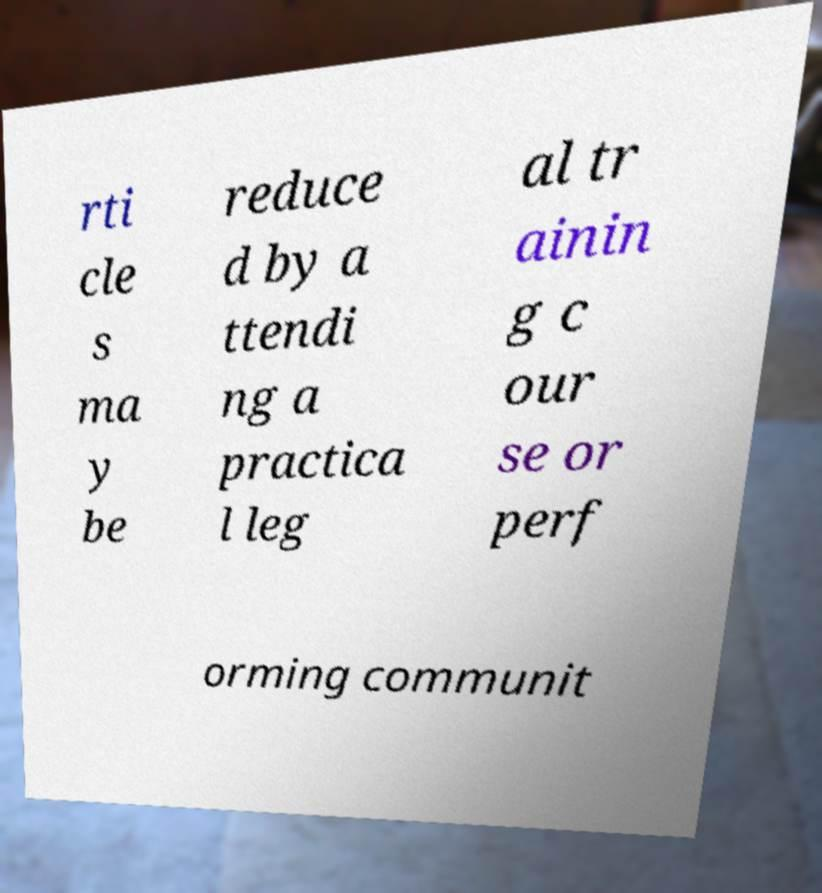Please identify and transcribe the text found in this image. rti cle s ma y be reduce d by a ttendi ng a practica l leg al tr ainin g c our se or perf orming communit 